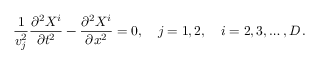<formula> <loc_0><loc_0><loc_500><loc_500>\frac { 1 } { v _ { j } ^ { 2 } } \frac { \partial ^ { 2 } X ^ { i } } { \partial t ^ { 2 } } - \frac { \partial ^ { 2 } X ^ { i } } { \partial x ^ { 2 } } = 0 , \quad j = 1 , 2 , \quad i = 2 , 3 , \dots , D \, { . }</formula> 